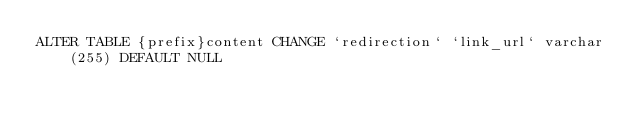Convert code to text. <code><loc_0><loc_0><loc_500><loc_500><_SQL_>ALTER TABLE {prefix}content CHANGE `redirection` `link_url` varchar(255) DEFAULT NULL</code> 